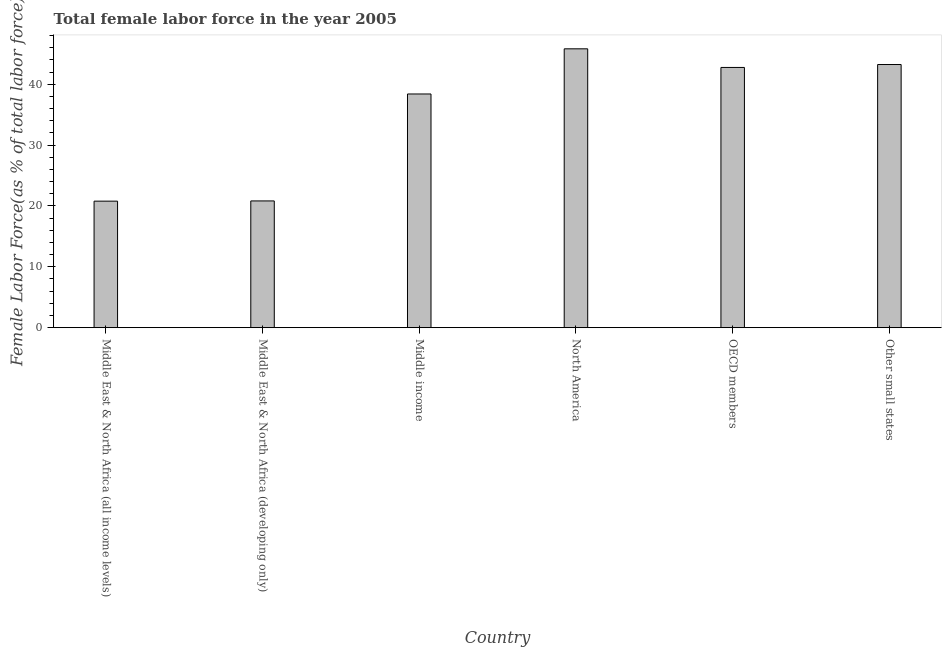Does the graph contain any zero values?
Your answer should be very brief. No. Does the graph contain grids?
Offer a very short reply. No. What is the title of the graph?
Your response must be concise. Total female labor force in the year 2005. What is the label or title of the X-axis?
Provide a succinct answer. Country. What is the label or title of the Y-axis?
Give a very brief answer. Female Labor Force(as % of total labor force). What is the total female labor force in Middle East & North Africa (developing only)?
Your response must be concise. 20.83. Across all countries, what is the maximum total female labor force?
Your response must be concise. 45.84. Across all countries, what is the minimum total female labor force?
Your response must be concise. 20.8. In which country was the total female labor force minimum?
Ensure brevity in your answer.  Middle East & North Africa (all income levels). What is the sum of the total female labor force?
Keep it short and to the point. 211.91. What is the difference between the total female labor force in Middle income and North America?
Provide a short and direct response. -7.42. What is the average total female labor force per country?
Provide a succinct answer. 35.32. What is the median total female labor force?
Keep it short and to the point. 40.59. What is the ratio of the total female labor force in North America to that in Other small states?
Offer a very short reply. 1.06. What is the difference between the highest and the second highest total female labor force?
Make the answer very short. 2.58. What is the difference between the highest and the lowest total female labor force?
Make the answer very short. 25.04. How many bars are there?
Provide a short and direct response. 6. Are all the bars in the graph horizontal?
Make the answer very short. No. What is the difference between two consecutive major ticks on the Y-axis?
Your answer should be very brief. 10. What is the Female Labor Force(as % of total labor force) in Middle East & North Africa (all income levels)?
Make the answer very short. 20.8. What is the Female Labor Force(as % of total labor force) in Middle East & North Africa (developing only)?
Your response must be concise. 20.83. What is the Female Labor Force(as % of total labor force) of Middle income?
Offer a very short reply. 38.41. What is the Female Labor Force(as % of total labor force) in North America?
Offer a terse response. 45.84. What is the Female Labor Force(as % of total labor force) in OECD members?
Your answer should be compact. 42.77. What is the Female Labor Force(as % of total labor force) of Other small states?
Offer a very short reply. 43.26. What is the difference between the Female Labor Force(as % of total labor force) in Middle East & North Africa (all income levels) and Middle East & North Africa (developing only)?
Provide a short and direct response. -0.04. What is the difference between the Female Labor Force(as % of total labor force) in Middle East & North Africa (all income levels) and Middle income?
Provide a succinct answer. -17.62. What is the difference between the Female Labor Force(as % of total labor force) in Middle East & North Africa (all income levels) and North America?
Offer a terse response. -25.04. What is the difference between the Female Labor Force(as % of total labor force) in Middle East & North Africa (all income levels) and OECD members?
Make the answer very short. -21.98. What is the difference between the Female Labor Force(as % of total labor force) in Middle East & North Africa (all income levels) and Other small states?
Provide a succinct answer. -22.46. What is the difference between the Female Labor Force(as % of total labor force) in Middle East & North Africa (developing only) and Middle income?
Your response must be concise. -17.58. What is the difference between the Female Labor Force(as % of total labor force) in Middle East & North Africa (developing only) and North America?
Ensure brevity in your answer.  -25. What is the difference between the Female Labor Force(as % of total labor force) in Middle East & North Africa (developing only) and OECD members?
Make the answer very short. -21.94. What is the difference between the Female Labor Force(as % of total labor force) in Middle East & North Africa (developing only) and Other small states?
Your response must be concise. -22.42. What is the difference between the Female Labor Force(as % of total labor force) in Middle income and North America?
Your response must be concise. -7.42. What is the difference between the Female Labor Force(as % of total labor force) in Middle income and OECD members?
Provide a succinct answer. -4.36. What is the difference between the Female Labor Force(as % of total labor force) in Middle income and Other small states?
Your answer should be very brief. -4.84. What is the difference between the Female Labor Force(as % of total labor force) in North America and OECD members?
Offer a terse response. 3.06. What is the difference between the Female Labor Force(as % of total labor force) in North America and Other small states?
Keep it short and to the point. 2.58. What is the difference between the Female Labor Force(as % of total labor force) in OECD members and Other small states?
Your response must be concise. -0.48. What is the ratio of the Female Labor Force(as % of total labor force) in Middle East & North Africa (all income levels) to that in Middle income?
Your answer should be compact. 0.54. What is the ratio of the Female Labor Force(as % of total labor force) in Middle East & North Africa (all income levels) to that in North America?
Make the answer very short. 0.45. What is the ratio of the Female Labor Force(as % of total labor force) in Middle East & North Africa (all income levels) to that in OECD members?
Ensure brevity in your answer.  0.49. What is the ratio of the Female Labor Force(as % of total labor force) in Middle East & North Africa (all income levels) to that in Other small states?
Give a very brief answer. 0.48. What is the ratio of the Female Labor Force(as % of total labor force) in Middle East & North Africa (developing only) to that in Middle income?
Give a very brief answer. 0.54. What is the ratio of the Female Labor Force(as % of total labor force) in Middle East & North Africa (developing only) to that in North America?
Provide a short and direct response. 0.46. What is the ratio of the Female Labor Force(as % of total labor force) in Middle East & North Africa (developing only) to that in OECD members?
Offer a terse response. 0.49. What is the ratio of the Female Labor Force(as % of total labor force) in Middle East & North Africa (developing only) to that in Other small states?
Make the answer very short. 0.48. What is the ratio of the Female Labor Force(as % of total labor force) in Middle income to that in North America?
Ensure brevity in your answer.  0.84. What is the ratio of the Female Labor Force(as % of total labor force) in Middle income to that in OECD members?
Your response must be concise. 0.9. What is the ratio of the Female Labor Force(as % of total labor force) in Middle income to that in Other small states?
Make the answer very short. 0.89. What is the ratio of the Female Labor Force(as % of total labor force) in North America to that in OECD members?
Offer a terse response. 1.07. What is the ratio of the Female Labor Force(as % of total labor force) in North America to that in Other small states?
Make the answer very short. 1.06. 